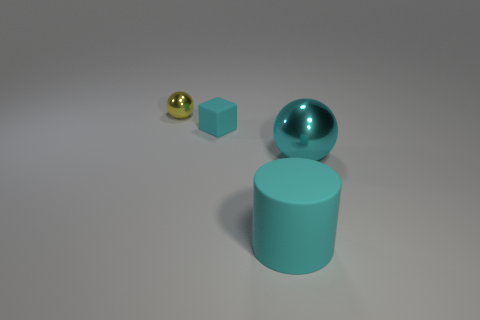Add 1 large purple things. How many objects exist? 5 Subtract 0 brown balls. How many objects are left? 4 Subtract 1 blocks. How many blocks are left? 0 Subtract all green cylinders. Subtract all purple spheres. How many cylinders are left? 1 Subtract all purple balls. How many green blocks are left? 0 Subtract all large rubber cylinders. Subtract all yellow shiny spheres. How many objects are left? 2 Add 1 big shiny spheres. How many big shiny spheres are left? 2 Add 2 big cyan matte objects. How many big cyan matte objects exist? 3 